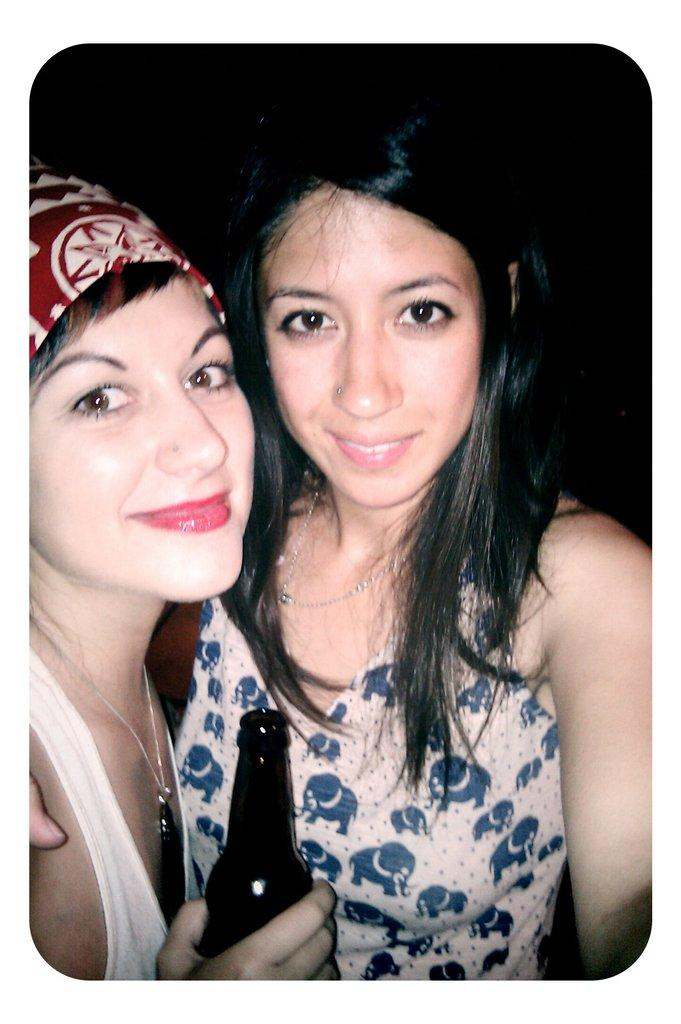How many women are in the image? There are two women in the foreground of the image. What is the facial expression of the women? Both women are smiling. What is the woman on the left holding? The woman on the left is holding a bottle in her hand. What can be observed about the background of the image? The background of the image is dark. What type of lumber is the woman on the right using to express her anger in the image? There is no lumber present in the image, and neither woman is expressing anger. 